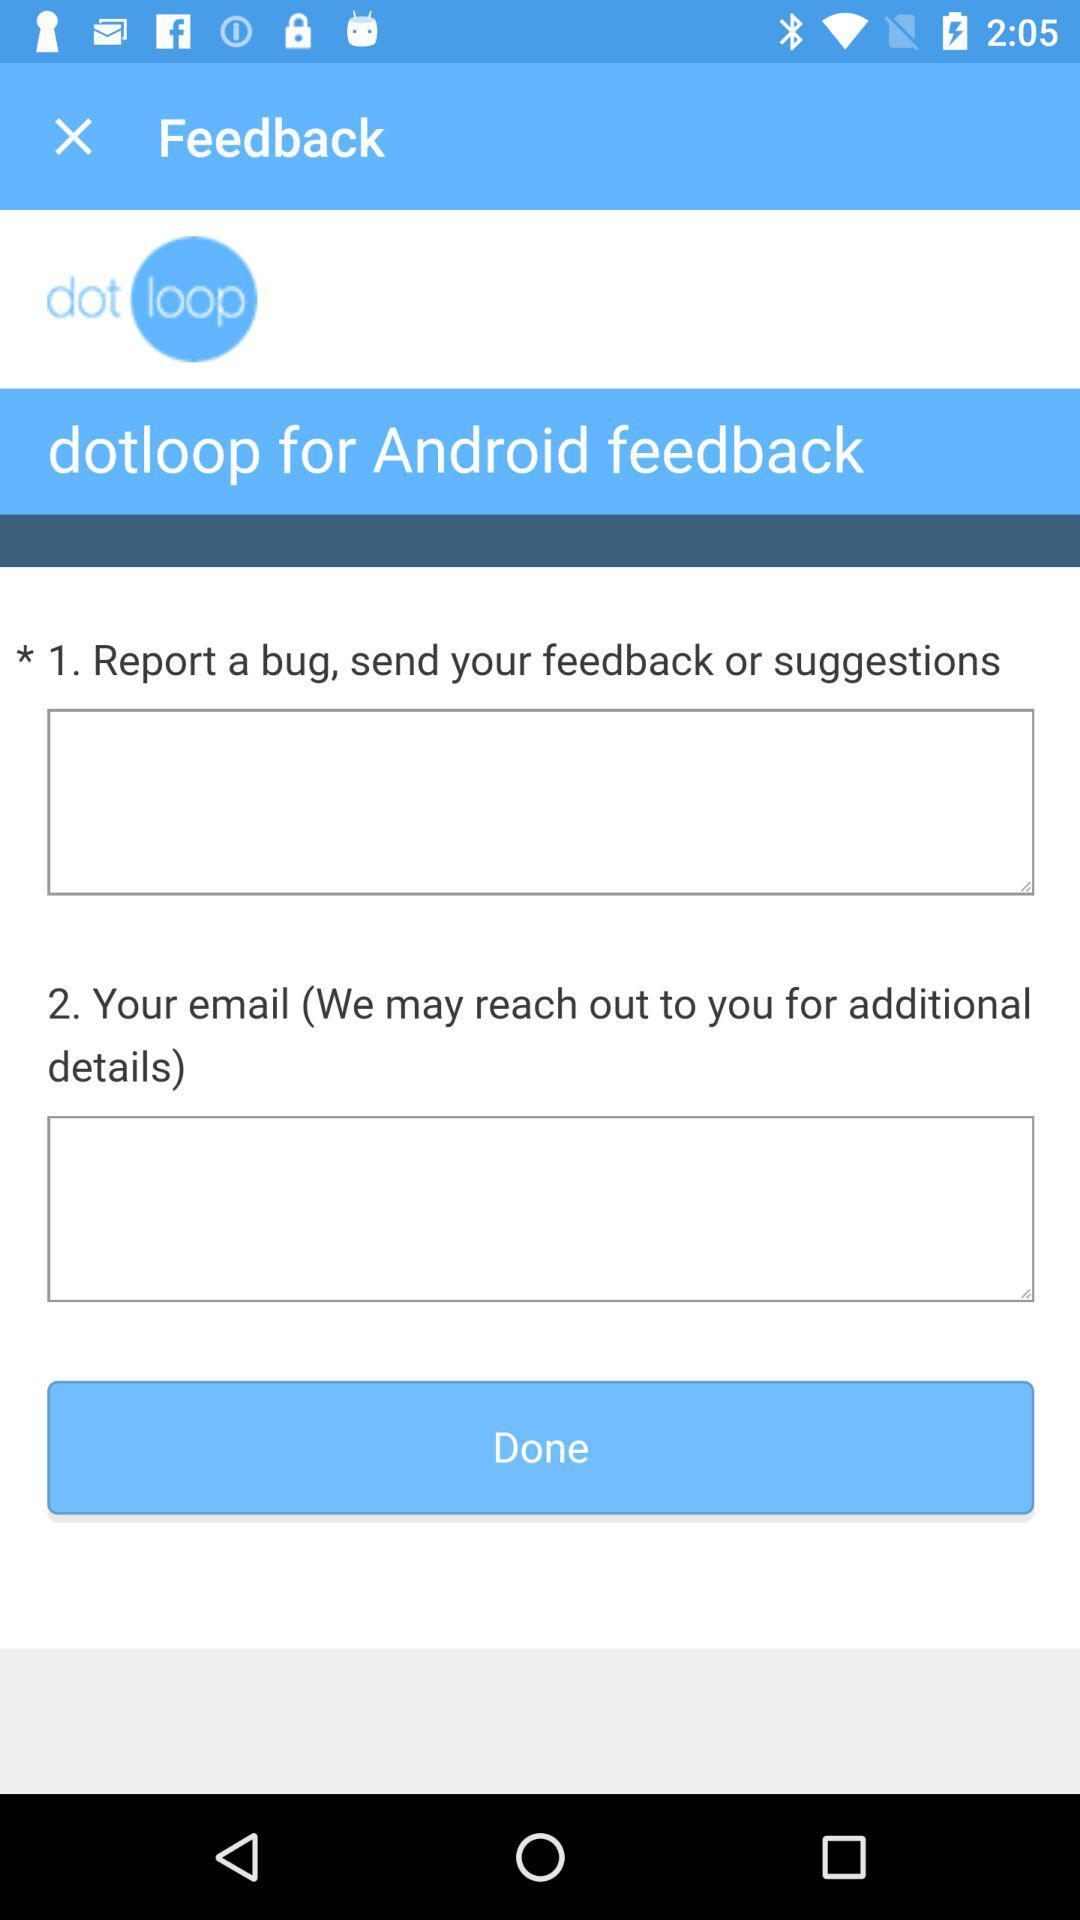What is the application name? The application name is "dot loop". 